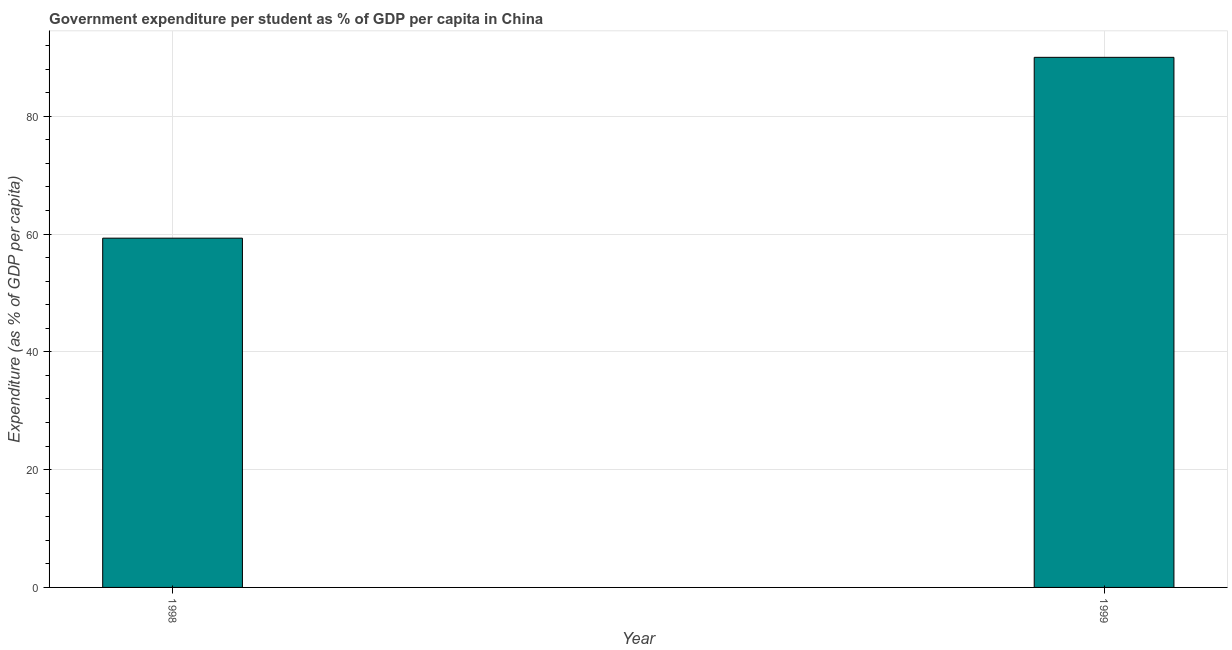Does the graph contain any zero values?
Provide a succinct answer. No. Does the graph contain grids?
Provide a succinct answer. Yes. What is the title of the graph?
Your answer should be very brief. Government expenditure per student as % of GDP per capita in China. What is the label or title of the X-axis?
Provide a short and direct response. Year. What is the label or title of the Y-axis?
Provide a succinct answer. Expenditure (as % of GDP per capita). What is the government expenditure per student in 1999?
Provide a succinct answer. 90. Across all years, what is the maximum government expenditure per student?
Offer a terse response. 90. Across all years, what is the minimum government expenditure per student?
Your answer should be compact. 59.3. What is the sum of the government expenditure per student?
Make the answer very short. 149.29. What is the difference between the government expenditure per student in 1998 and 1999?
Make the answer very short. -30.7. What is the average government expenditure per student per year?
Offer a very short reply. 74.65. What is the median government expenditure per student?
Make the answer very short. 74.65. In how many years, is the government expenditure per student greater than 88 %?
Your response must be concise. 1. Do a majority of the years between 1999 and 1998 (inclusive) have government expenditure per student greater than 16 %?
Keep it short and to the point. No. What is the ratio of the government expenditure per student in 1998 to that in 1999?
Make the answer very short. 0.66. Is the government expenditure per student in 1998 less than that in 1999?
Your answer should be compact. Yes. In how many years, is the government expenditure per student greater than the average government expenditure per student taken over all years?
Offer a very short reply. 1. How many bars are there?
Keep it short and to the point. 2. How many years are there in the graph?
Provide a short and direct response. 2. Are the values on the major ticks of Y-axis written in scientific E-notation?
Your answer should be compact. No. What is the Expenditure (as % of GDP per capita) in 1998?
Make the answer very short. 59.3. What is the Expenditure (as % of GDP per capita) of 1999?
Your answer should be very brief. 90. What is the difference between the Expenditure (as % of GDP per capita) in 1998 and 1999?
Provide a short and direct response. -30.7. What is the ratio of the Expenditure (as % of GDP per capita) in 1998 to that in 1999?
Offer a terse response. 0.66. 